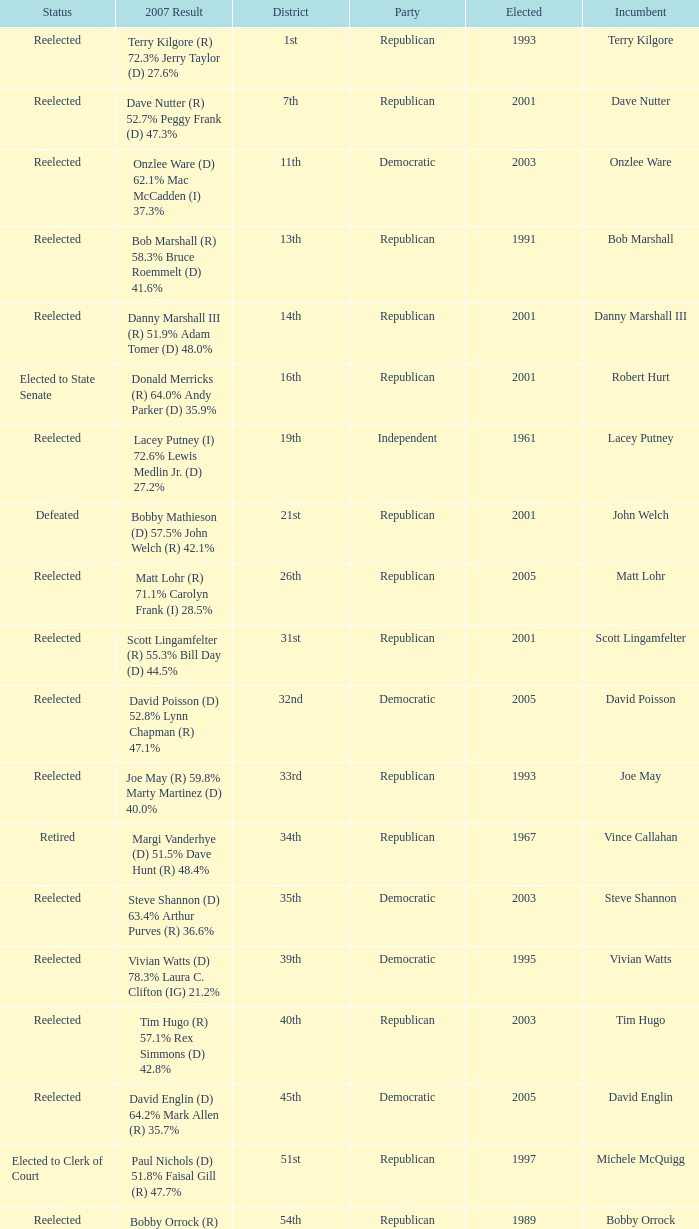What district is incument terry kilgore from? 1st. 